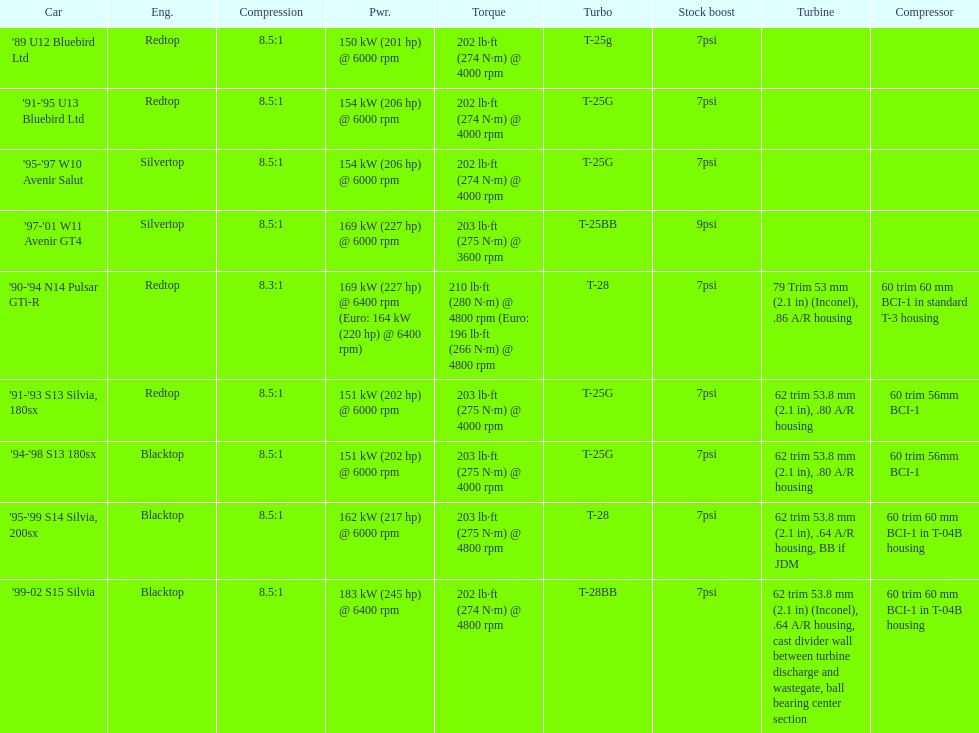What are all of the cars? '89 U12 Bluebird Ltd, '91-'95 U13 Bluebird Ltd, '95-'97 W10 Avenir Salut, '97-'01 W11 Avenir GT4, '90-'94 N14 Pulsar GTi-R, '91-'93 S13 Silvia, 180sx, '94-'98 S13 180sx, '95-'99 S14 Silvia, 200sx, '99-02 S15 Silvia. What is their rated power? 150 kW (201 hp) @ 6000 rpm, 154 kW (206 hp) @ 6000 rpm, 154 kW (206 hp) @ 6000 rpm, 169 kW (227 hp) @ 6000 rpm, 169 kW (227 hp) @ 6400 rpm (Euro: 164 kW (220 hp) @ 6400 rpm), 151 kW (202 hp) @ 6000 rpm, 151 kW (202 hp) @ 6000 rpm, 162 kW (217 hp) @ 6000 rpm, 183 kW (245 hp) @ 6400 rpm. Which car has the most power? '99-02 S15 Silvia. 